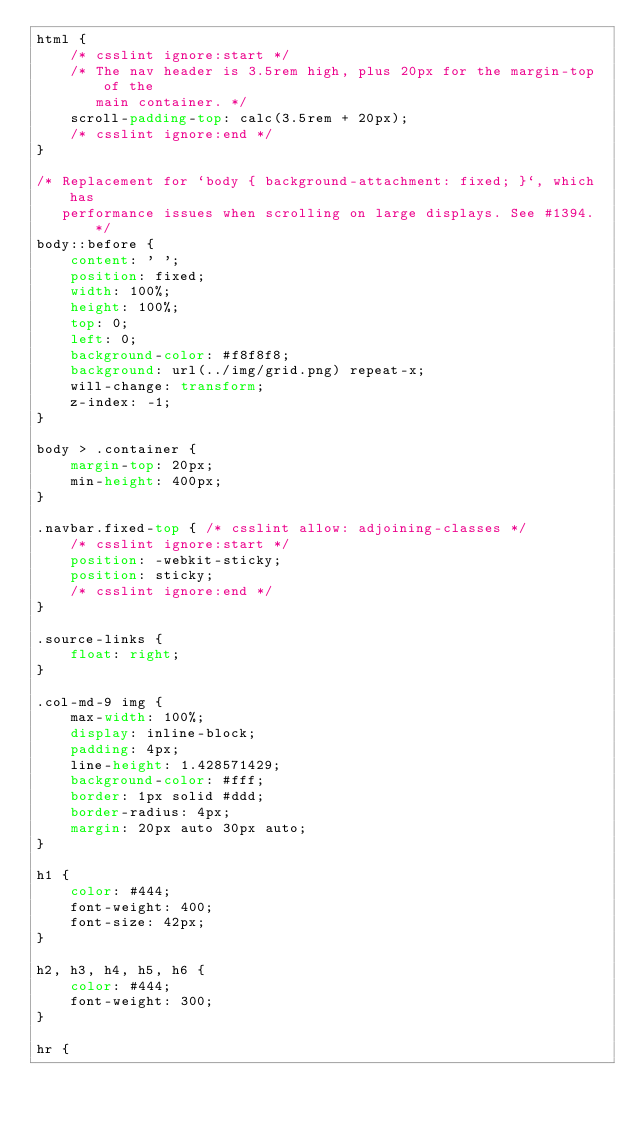<code> <loc_0><loc_0><loc_500><loc_500><_CSS_>html {
    /* csslint ignore:start */
    /* The nav header is 3.5rem high, plus 20px for the margin-top of the
       main container. */
    scroll-padding-top: calc(3.5rem + 20px);
    /* csslint ignore:end */
}

/* Replacement for `body { background-attachment: fixed; }`, which has
   performance issues when scrolling on large displays. See #1394. */
body::before {
    content: ' ';
    position: fixed;
    width: 100%;
    height: 100%;
    top: 0;
    left: 0;
    background-color: #f8f8f8;
    background: url(../img/grid.png) repeat-x;
    will-change: transform;
    z-index: -1;
}

body > .container {
    margin-top: 20px;
    min-height: 400px;
}

.navbar.fixed-top { /* csslint allow: adjoining-classes */
    /* csslint ignore:start */
    position: -webkit-sticky;
    position: sticky;
    /* csslint ignore:end */
}

.source-links {
    float: right;
}

.col-md-9 img {
    max-width: 100%;
    display: inline-block;
    padding: 4px;
    line-height: 1.428571429;
    background-color: #fff;
    border: 1px solid #ddd;
    border-radius: 4px;
    margin: 20px auto 30px auto;
}

h1 {
    color: #444;
    font-weight: 400;
    font-size: 42px;
}

h2, h3, h4, h5, h6 {
    color: #444;
    font-weight: 300;
}

hr {</code> 